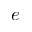<formula> <loc_0><loc_0><loc_500><loc_500>e</formula> 